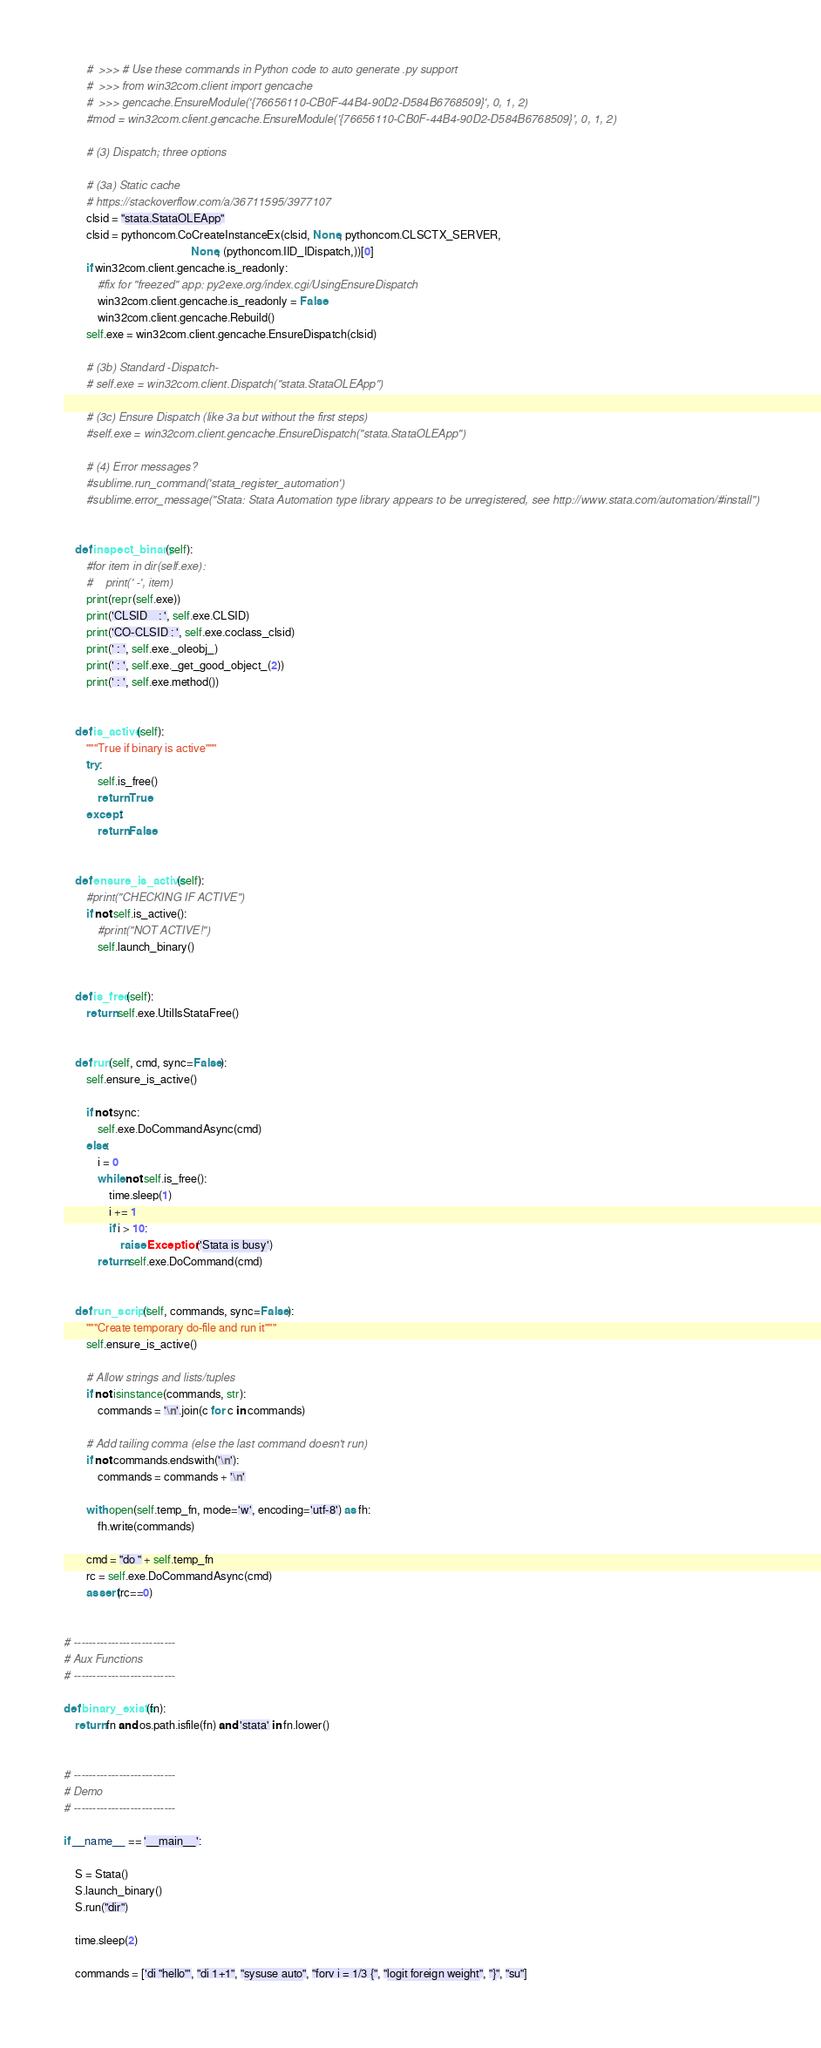Convert code to text. <code><loc_0><loc_0><loc_500><loc_500><_Python_>        #  >>> # Use these commands in Python code to auto generate .py support
        #  >>> from win32com.client import gencache
        #  >>> gencache.EnsureModule('{76656110-CB0F-44B4-90D2-D584B6768509}', 0, 1, 2)
        #mod = win32com.client.gencache.EnsureModule('{76656110-CB0F-44B4-90D2-D584B6768509}', 0, 1, 2)

        # (3) Dispatch; three options

        # (3a) Static cache
        # https://stackoverflow.com/a/36711595/3977107
        clsid = "stata.StataOLEApp"
        clsid = pythoncom.CoCreateInstanceEx(clsid, None, pythoncom.CLSCTX_SERVER,
                                             None, (pythoncom.IID_IDispatch,))[0]
        if win32com.client.gencache.is_readonly:
            #fix for "freezed" app: py2exe.org/index.cgi/UsingEnsureDispatch
            win32com.client.gencache.is_readonly = False
            win32com.client.gencache.Rebuild()
        self.exe = win32com.client.gencache.EnsureDispatch(clsid)

        # (3b) Standard -Dispatch-
        # self.exe = win32com.client.Dispatch("stata.StataOLEApp")

        # (3c) Ensure Dispatch (like 3a but without the first steps)
        #self.exe = win32com.client.gencache.EnsureDispatch("stata.StataOLEApp")

        # (4) Error messages?
        #sublime.run_command('stata_register_automation')
        #sublime.error_message("Stata: Stata Automation type library appears to be unregistered, see http://www.stata.com/automation/#install")


    def inspect_binary(self):
        #for item in dir(self.exe):
        #    print(' -', item)
        print(repr(self.exe))
        print('CLSID    : ', self.exe.CLSID)
        print('CO-CLSID : ', self.exe.coclass_clsid)
        print(' : ', self.exe._oleobj_)
        print(' : ', self.exe._get_good_object_(2))
        print(' : ', self.exe.method())


    def is_active(self):
        """True if binary is active"""
        try:
            self.is_free()
            return True
        except:
            return False


    def ensure_is_active(self):
        #print("CHECKING IF ACTIVE")
        if not self.is_active():
            #print("NOT ACTIVE!")
            self.launch_binary()


    def is_free(self):
        return self.exe.UtilIsStataFree()


    def run(self, cmd, sync=False):
        self.ensure_is_active()
        
        if not sync:
            self.exe.DoCommandAsync(cmd)
        else:
            i = 0
            while not self.is_free():
                time.sleep(1)
                i += 1
                if i > 10:
                    raise Exception('Stata is busy')
            return self.exe.DoCommand(cmd)


    def run_script(self, commands, sync=False):
        """Create temporary do-file and run it"""
        self.ensure_is_active()
        
        # Allow strings and lists/tuples
        if not isinstance(commands, str):
            commands = '\n'.join(c for c in commands)

        # Add tailing comma (else the last command doesn't run)
        if not commands.endswith('\n'):
            commands = commands + '\n'

        with open(self.temp_fn, mode='w', encoding='utf-8') as fh:
            fh.write(commands)

        cmd = "do " + self.temp_fn
        rc = self.exe.DoCommandAsync(cmd)
        assert(rc==0)


# ---------------------------
# Aux Functions
# ---------------------------

def binary_exists(fn):
    return fn and os.path.isfile(fn) and 'stata' in fn.lower()


# ---------------------------
# Demo
# ---------------------------

if __name__ == '__main__':
    
    S = Stata()
    S.launch_binary()
    S.run("dir")
    
    time.sleep(2)

    commands = ['di "hello"', "di 1+1", "sysuse auto", "forv i = 1/3 {", "logit foreign weight", "}", "su"]</code> 